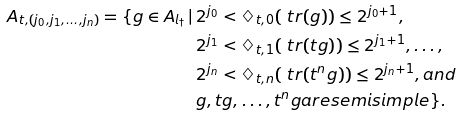<formula> <loc_0><loc_0><loc_500><loc_500>A _ { t , ( j _ { 0 } , j _ { 1 } , \dots , j _ { n } ) } = \{ g \in A _ { l _ { \dagger } } \, | \, & 2 ^ { j _ { 0 } } < \diamondsuit _ { t , 0 } ( \ t r ( g ) ) \leq 2 ^ { j _ { 0 } + 1 } , \\ & 2 ^ { j _ { 1 } } < \diamondsuit _ { t , 1 } ( \ t r ( t g ) ) \leq 2 ^ { j _ { 1 } + 1 } , \dots , \\ & 2 ^ { j _ { n } } < \diamondsuit _ { t , n } ( \ t r ( t ^ { n } g ) ) \leq 2 ^ { j _ { n } + 1 } , a n d \\ & g , t g , \dots , t ^ { n } g a r e s e m i s i m p l e \} .</formula> 